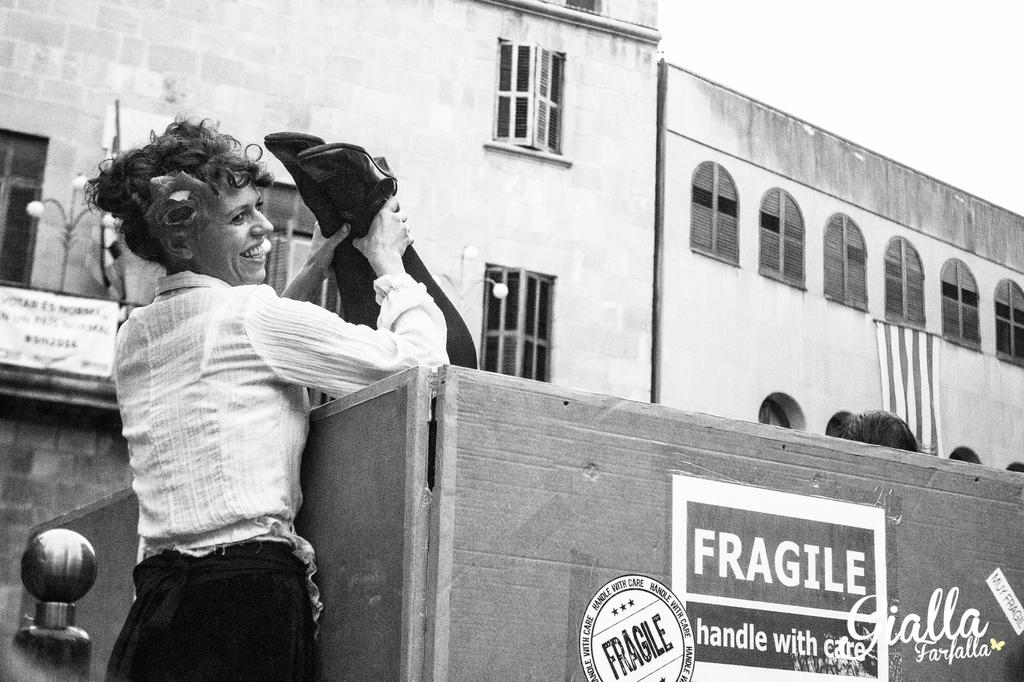What is the color scheme of the image? The image is black and white. Who is present in the image? There is a woman in the image. What is the woman holding in the image? The woman is holding legs in a box. What can be seen in the distance in the image? There are buildings in the background of the image. What type of ink can be seen on the moon in the image? There is no moon present in the image, and therefore no ink can be seen on it. What type of work is the woman doing in the image? The image does not provide enough information to determine the type of work the woman is doing. 